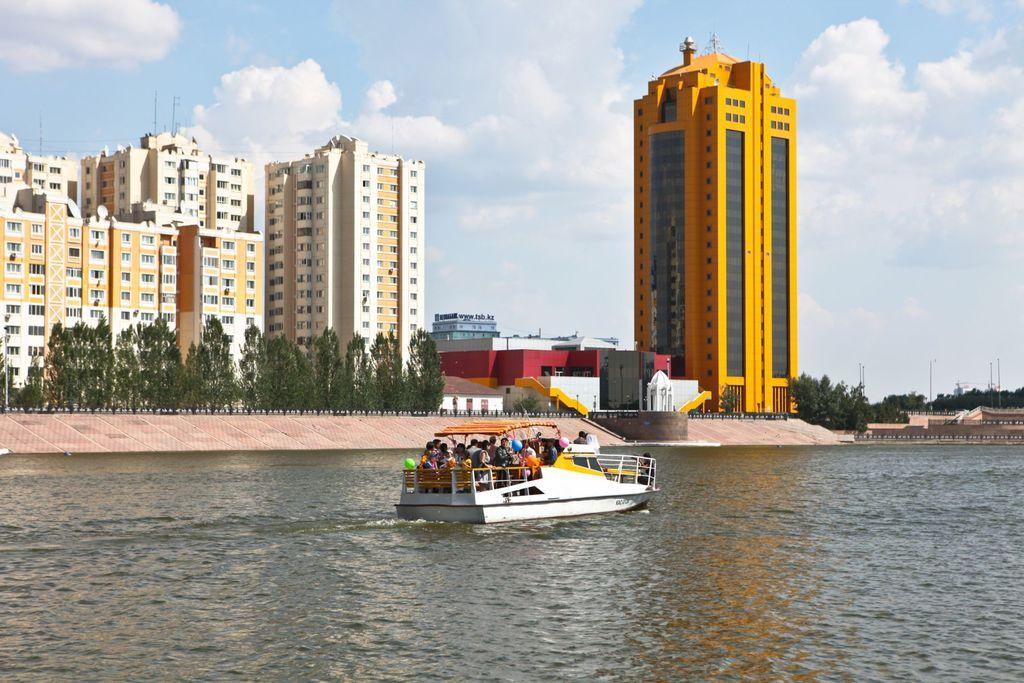What are the people in the image doing? The people in the image are standing on the water surface. What can be seen in the background of the image? There are buildings and trees visible in the image. What type of cough medicine is being advertised on the buildings in the image? There is no advertisement for cough medicine visible on the buildings in the image. 